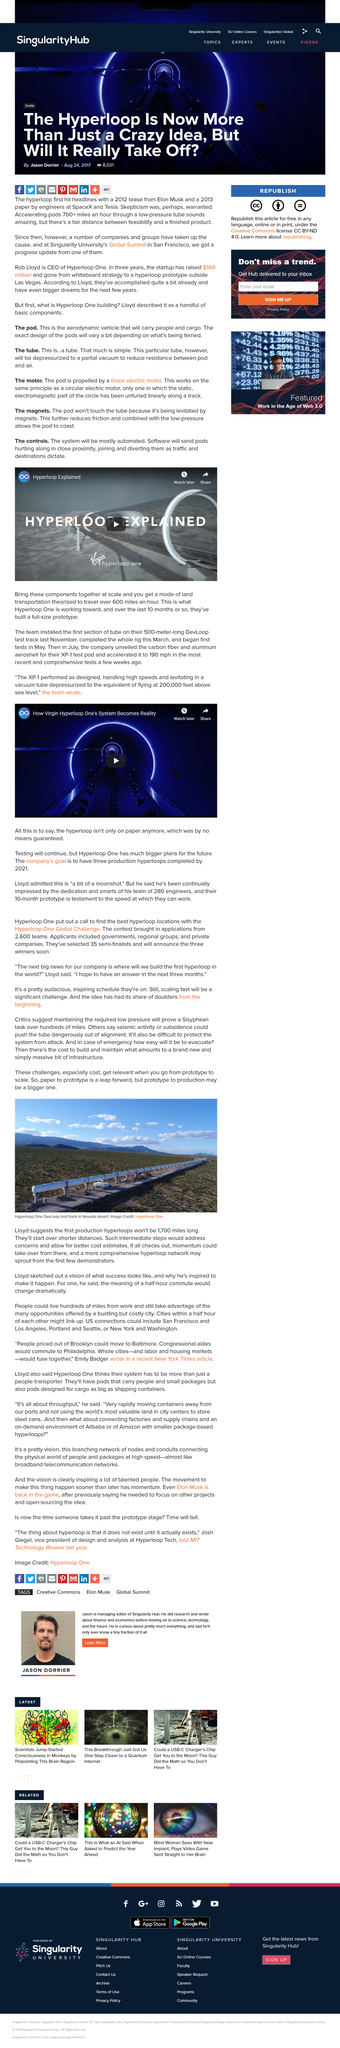Give some essential details in this illustration. The first production hyperloops are expected to be less than 1,700 miles in length. The cost of production for actual hyperloops will increase. The DevLoop test track in the Nevada desert is a prototype of the Hyperloop, a technology that propels vehicles through a low-pressure tube using electromagnetic propulsion. 